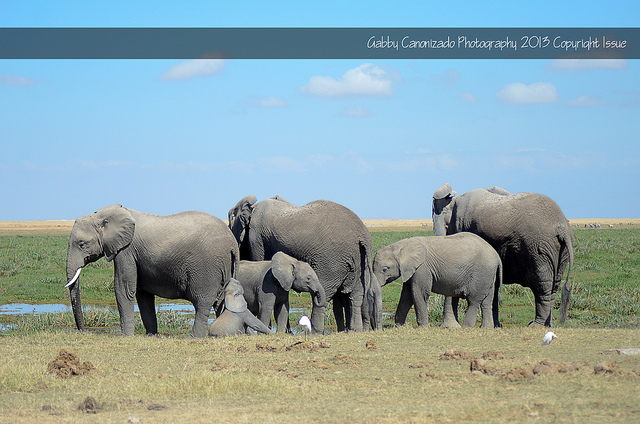Read and extract the text from this image. Gabby Cananlzado Photography 2013 copurlaqht Issue 